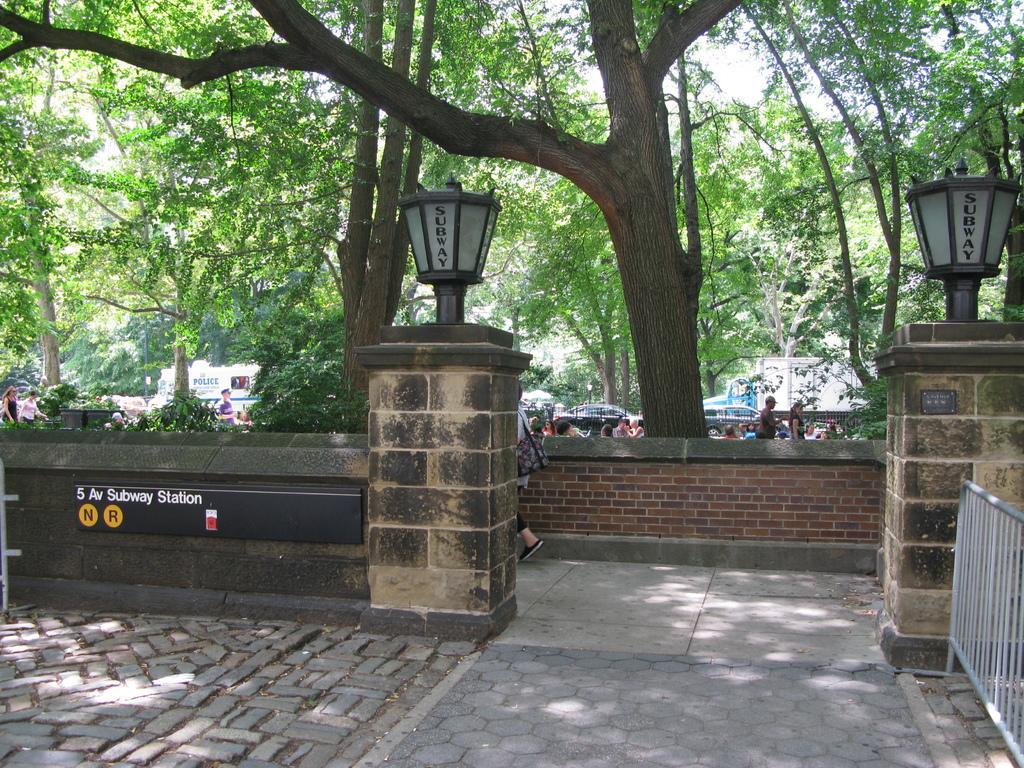Can you describe this image briefly? Above this compound walls there are lamps and board. In-front of this compound wall there is a grill. Background of the image we can see brick wall, people, vehicles and trees. Through the trees sky is visible. 